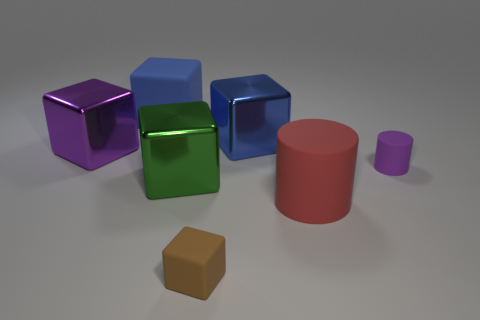There is a large metal object that is in front of the tiny thing on the right side of the red thing; what color is it?
Ensure brevity in your answer.  Green. There is a rubber block that is the same size as the green shiny cube; what is its color?
Keep it short and to the point. Blue. How many cubes are both behind the green shiny block and right of the big purple metal block?
Keep it short and to the point. 2. The large thing that is the same color as the small cylinder is what shape?
Provide a succinct answer. Cube. There is a big thing that is both on the right side of the brown block and behind the red matte cylinder; what material is it made of?
Provide a short and direct response. Metal. Is the number of blue shiny objects in front of the green thing less than the number of large matte cubes in front of the big red matte cylinder?
Your answer should be very brief. No. The blue thing that is the same material as the large red cylinder is what size?
Your answer should be very brief. Large. Are there any other things that have the same color as the large matte cube?
Your response must be concise. Yes. Are the green block and the object on the left side of the big blue rubber object made of the same material?
Provide a succinct answer. Yes. What material is the big green thing that is the same shape as the small brown thing?
Give a very brief answer. Metal. 